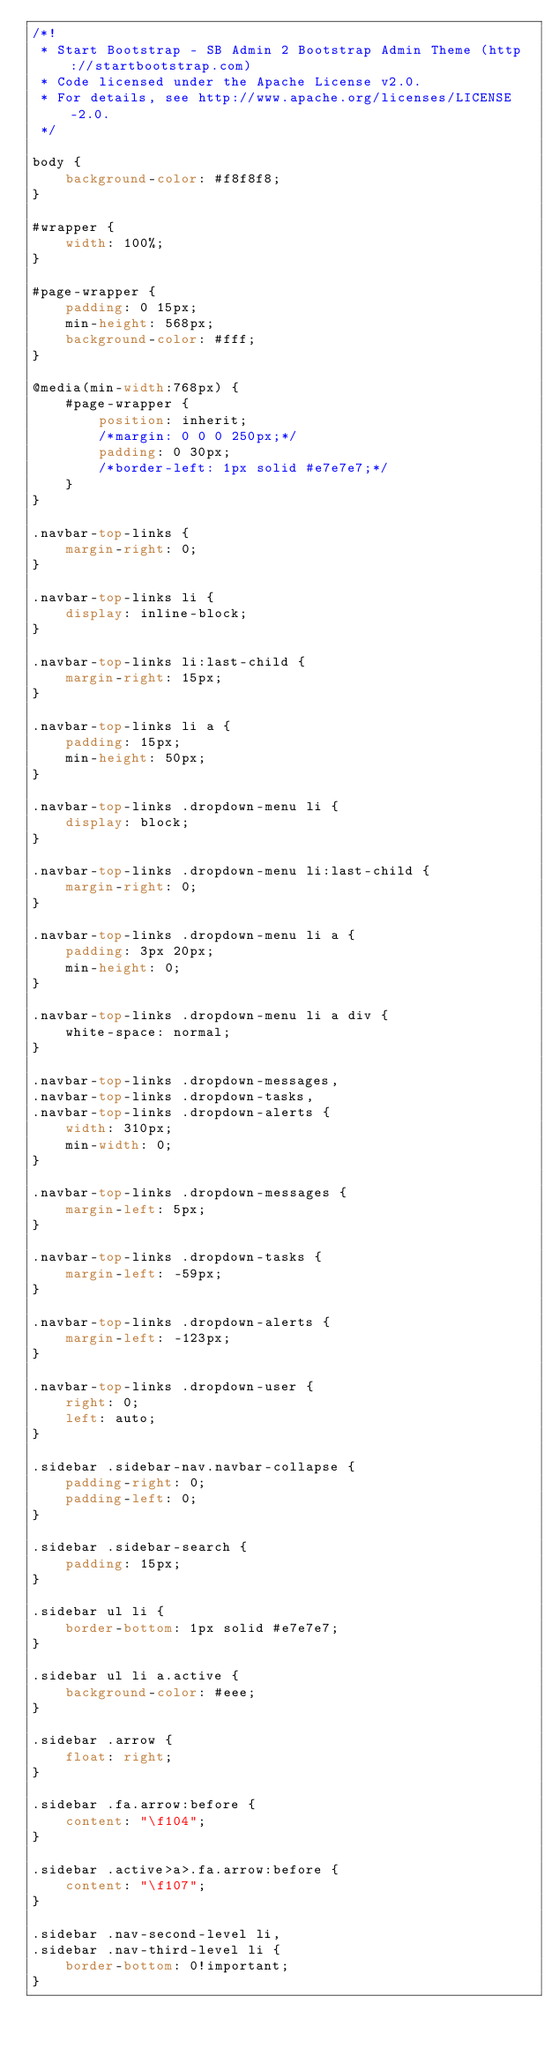Convert code to text. <code><loc_0><loc_0><loc_500><loc_500><_CSS_>/*!
 * Start Bootstrap - SB Admin 2 Bootstrap Admin Theme (http://startbootstrap.com)
 * Code licensed under the Apache License v2.0.
 * For details, see http://www.apache.org/licenses/LICENSE-2.0.
 */

body {
    background-color: #f8f8f8;
}

#wrapper {
    width: 100%;
}

#page-wrapper {
    padding: 0 15px;
    min-height: 568px;
    background-color: #fff;
}

@media(min-width:768px) {
    #page-wrapper {
        position: inherit;
        /*margin: 0 0 0 250px;*/
        padding: 0 30px;
        /*border-left: 1px solid #e7e7e7;*/
    }
}

.navbar-top-links {
    margin-right: 0;
}

.navbar-top-links li {
    display: inline-block;
}

.navbar-top-links li:last-child {
    margin-right: 15px;
}

.navbar-top-links li a {
    padding: 15px;
    min-height: 50px;
}

.navbar-top-links .dropdown-menu li {
    display: block;
}

.navbar-top-links .dropdown-menu li:last-child {
    margin-right: 0;
}

.navbar-top-links .dropdown-menu li a {
    padding: 3px 20px;
    min-height: 0;
}

.navbar-top-links .dropdown-menu li a div {
    white-space: normal;
}

.navbar-top-links .dropdown-messages,
.navbar-top-links .dropdown-tasks,
.navbar-top-links .dropdown-alerts {
    width: 310px;
    min-width: 0;
}

.navbar-top-links .dropdown-messages {
    margin-left: 5px;
}

.navbar-top-links .dropdown-tasks {
    margin-left: -59px;
}

.navbar-top-links .dropdown-alerts {
    margin-left: -123px;
}

.navbar-top-links .dropdown-user {
    right: 0;
    left: auto;
}

.sidebar .sidebar-nav.navbar-collapse {
    padding-right: 0;
    padding-left: 0;
}

.sidebar .sidebar-search {
    padding: 15px;
}

.sidebar ul li {
    border-bottom: 1px solid #e7e7e7;
}

.sidebar ul li a.active {
    background-color: #eee;
}

.sidebar .arrow {
    float: right;
}

.sidebar .fa.arrow:before {
    content: "\f104";
}

.sidebar .active>a>.fa.arrow:before {
    content: "\f107";
}

.sidebar .nav-second-level li,
.sidebar .nav-third-level li {
    border-bottom: 0!important;
}
</code> 